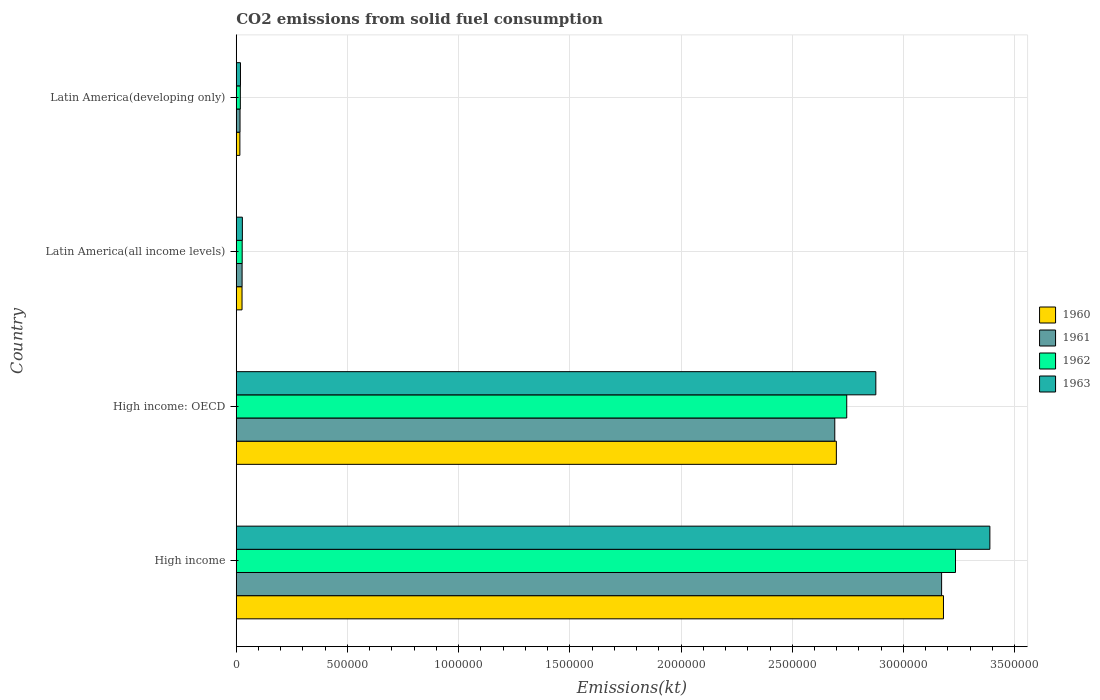How many different coloured bars are there?
Offer a very short reply. 4. How many groups of bars are there?
Your answer should be compact. 4. How many bars are there on the 2nd tick from the top?
Your response must be concise. 4. What is the label of the 2nd group of bars from the top?
Provide a succinct answer. Latin America(all income levels). In how many cases, is the number of bars for a given country not equal to the number of legend labels?
Your answer should be compact. 0. What is the amount of CO2 emitted in 1961 in High income?
Offer a very short reply. 3.17e+06. Across all countries, what is the maximum amount of CO2 emitted in 1962?
Your answer should be compact. 3.23e+06. Across all countries, what is the minimum amount of CO2 emitted in 1961?
Ensure brevity in your answer.  1.70e+04. In which country was the amount of CO2 emitted in 1962 maximum?
Keep it short and to the point. High income. In which country was the amount of CO2 emitted in 1962 minimum?
Your answer should be compact. Latin America(developing only). What is the total amount of CO2 emitted in 1963 in the graph?
Give a very brief answer. 6.31e+06. What is the difference between the amount of CO2 emitted in 1960 in High income: OECD and that in Latin America(all income levels)?
Offer a terse response. 2.67e+06. What is the difference between the amount of CO2 emitted in 1963 in Latin America(all income levels) and the amount of CO2 emitted in 1961 in High income: OECD?
Keep it short and to the point. -2.66e+06. What is the average amount of CO2 emitted in 1963 per country?
Your answer should be very brief. 1.58e+06. What is the difference between the amount of CO2 emitted in 1963 and amount of CO2 emitted in 1962 in Latin America(all income levels)?
Offer a very short reply. 858.84. In how many countries, is the amount of CO2 emitted in 1960 greater than 3200000 kt?
Offer a very short reply. 0. What is the ratio of the amount of CO2 emitted in 1961 in High income: OECD to that in Latin America(all income levels)?
Your answer should be very brief. 102.49. Is the amount of CO2 emitted in 1962 in High income: OECD less than that in Latin America(developing only)?
Provide a short and direct response. No. What is the difference between the highest and the second highest amount of CO2 emitted in 1962?
Your answer should be compact. 4.89e+05. What is the difference between the highest and the lowest amount of CO2 emitted in 1961?
Ensure brevity in your answer.  3.15e+06. In how many countries, is the amount of CO2 emitted in 1961 greater than the average amount of CO2 emitted in 1961 taken over all countries?
Offer a very short reply. 2. Is the sum of the amount of CO2 emitted in 1961 in High income: OECD and Latin America(all income levels) greater than the maximum amount of CO2 emitted in 1960 across all countries?
Provide a succinct answer. No. Is it the case that in every country, the sum of the amount of CO2 emitted in 1962 and amount of CO2 emitted in 1960 is greater than the sum of amount of CO2 emitted in 1963 and amount of CO2 emitted in 1961?
Your answer should be very brief. No. What does the 4th bar from the bottom in Latin America(developing only) represents?
Keep it short and to the point. 1963. How many bars are there?
Keep it short and to the point. 16. Are all the bars in the graph horizontal?
Keep it short and to the point. Yes. What is the difference between two consecutive major ticks on the X-axis?
Offer a very short reply. 5.00e+05. Where does the legend appear in the graph?
Your answer should be compact. Center right. How many legend labels are there?
Your answer should be compact. 4. What is the title of the graph?
Keep it short and to the point. CO2 emissions from solid fuel consumption. Does "1963" appear as one of the legend labels in the graph?
Provide a succinct answer. Yes. What is the label or title of the X-axis?
Ensure brevity in your answer.  Emissions(kt). What is the Emissions(kt) of 1960 in High income?
Offer a terse response. 3.18e+06. What is the Emissions(kt) in 1961 in High income?
Your answer should be very brief. 3.17e+06. What is the Emissions(kt) of 1962 in High income?
Offer a terse response. 3.23e+06. What is the Emissions(kt) in 1963 in High income?
Offer a very short reply. 3.39e+06. What is the Emissions(kt) in 1960 in High income: OECD?
Give a very brief answer. 2.70e+06. What is the Emissions(kt) of 1961 in High income: OECD?
Make the answer very short. 2.69e+06. What is the Emissions(kt) of 1962 in High income: OECD?
Give a very brief answer. 2.75e+06. What is the Emissions(kt) of 1963 in High income: OECD?
Make the answer very short. 2.88e+06. What is the Emissions(kt) in 1960 in Latin America(all income levels)?
Keep it short and to the point. 2.60e+04. What is the Emissions(kt) in 1961 in Latin America(all income levels)?
Keep it short and to the point. 2.63e+04. What is the Emissions(kt) of 1962 in Latin America(all income levels)?
Your response must be concise. 2.67e+04. What is the Emissions(kt) of 1963 in Latin America(all income levels)?
Your answer should be compact. 2.75e+04. What is the Emissions(kt) of 1960 in Latin America(developing only)?
Keep it short and to the point. 1.62e+04. What is the Emissions(kt) of 1961 in Latin America(developing only)?
Ensure brevity in your answer.  1.70e+04. What is the Emissions(kt) in 1962 in Latin America(developing only)?
Your answer should be compact. 1.83e+04. What is the Emissions(kt) in 1963 in Latin America(developing only)?
Offer a terse response. 1.90e+04. Across all countries, what is the maximum Emissions(kt) of 1960?
Ensure brevity in your answer.  3.18e+06. Across all countries, what is the maximum Emissions(kt) of 1961?
Give a very brief answer. 3.17e+06. Across all countries, what is the maximum Emissions(kt) of 1962?
Ensure brevity in your answer.  3.23e+06. Across all countries, what is the maximum Emissions(kt) in 1963?
Your response must be concise. 3.39e+06. Across all countries, what is the minimum Emissions(kt) in 1960?
Provide a short and direct response. 1.62e+04. Across all countries, what is the minimum Emissions(kt) of 1961?
Offer a very short reply. 1.70e+04. Across all countries, what is the minimum Emissions(kt) of 1962?
Ensure brevity in your answer.  1.83e+04. Across all countries, what is the minimum Emissions(kt) of 1963?
Offer a very short reply. 1.90e+04. What is the total Emissions(kt) in 1960 in the graph?
Your answer should be very brief. 5.92e+06. What is the total Emissions(kt) in 1961 in the graph?
Your answer should be very brief. 5.91e+06. What is the total Emissions(kt) in 1962 in the graph?
Ensure brevity in your answer.  6.02e+06. What is the total Emissions(kt) in 1963 in the graph?
Make the answer very short. 6.31e+06. What is the difference between the Emissions(kt) of 1960 in High income and that in High income: OECD?
Provide a short and direct response. 4.82e+05. What is the difference between the Emissions(kt) of 1961 in High income and that in High income: OECD?
Provide a short and direct response. 4.80e+05. What is the difference between the Emissions(kt) of 1962 in High income and that in High income: OECD?
Give a very brief answer. 4.89e+05. What is the difference between the Emissions(kt) of 1963 in High income and that in High income: OECD?
Ensure brevity in your answer.  5.13e+05. What is the difference between the Emissions(kt) of 1960 in High income and that in Latin America(all income levels)?
Ensure brevity in your answer.  3.15e+06. What is the difference between the Emissions(kt) of 1961 in High income and that in Latin America(all income levels)?
Your response must be concise. 3.15e+06. What is the difference between the Emissions(kt) of 1962 in High income and that in Latin America(all income levels)?
Offer a terse response. 3.21e+06. What is the difference between the Emissions(kt) of 1963 in High income and that in Latin America(all income levels)?
Your response must be concise. 3.36e+06. What is the difference between the Emissions(kt) in 1960 in High income and that in Latin America(developing only)?
Offer a terse response. 3.16e+06. What is the difference between the Emissions(kt) in 1961 in High income and that in Latin America(developing only)?
Provide a short and direct response. 3.15e+06. What is the difference between the Emissions(kt) in 1962 in High income and that in Latin America(developing only)?
Provide a short and direct response. 3.22e+06. What is the difference between the Emissions(kt) in 1963 in High income and that in Latin America(developing only)?
Your answer should be compact. 3.37e+06. What is the difference between the Emissions(kt) of 1960 in High income: OECD and that in Latin America(all income levels)?
Offer a very short reply. 2.67e+06. What is the difference between the Emissions(kt) in 1961 in High income: OECD and that in Latin America(all income levels)?
Offer a very short reply. 2.67e+06. What is the difference between the Emissions(kt) in 1962 in High income: OECD and that in Latin America(all income levels)?
Provide a short and direct response. 2.72e+06. What is the difference between the Emissions(kt) in 1963 in High income: OECD and that in Latin America(all income levels)?
Your response must be concise. 2.85e+06. What is the difference between the Emissions(kt) in 1960 in High income: OECD and that in Latin America(developing only)?
Offer a very short reply. 2.68e+06. What is the difference between the Emissions(kt) of 1961 in High income: OECD and that in Latin America(developing only)?
Provide a short and direct response. 2.67e+06. What is the difference between the Emissions(kt) of 1962 in High income: OECD and that in Latin America(developing only)?
Provide a succinct answer. 2.73e+06. What is the difference between the Emissions(kt) of 1963 in High income: OECD and that in Latin America(developing only)?
Your answer should be compact. 2.86e+06. What is the difference between the Emissions(kt) of 1960 in Latin America(all income levels) and that in Latin America(developing only)?
Make the answer very short. 9759.8. What is the difference between the Emissions(kt) of 1961 in Latin America(all income levels) and that in Latin America(developing only)?
Your answer should be very brief. 9282.45. What is the difference between the Emissions(kt) of 1962 in Latin America(all income levels) and that in Latin America(developing only)?
Your response must be concise. 8301.83. What is the difference between the Emissions(kt) of 1963 in Latin America(all income levels) and that in Latin America(developing only)?
Give a very brief answer. 8542.91. What is the difference between the Emissions(kt) in 1960 in High income and the Emissions(kt) in 1961 in High income: OECD?
Give a very brief answer. 4.89e+05. What is the difference between the Emissions(kt) of 1960 in High income and the Emissions(kt) of 1962 in High income: OECD?
Offer a terse response. 4.35e+05. What is the difference between the Emissions(kt) in 1960 in High income and the Emissions(kt) in 1963 in High income: OECD?
Offer a very short reply. 3.04e+05. What is the difference between the Emissions(kt) of 1961 in High income and the Emissions(kt) of 1962 in High income: OECD?
Your response must be concise. 4.27e+05. What is the difference between the Emissions(kt) in 1961 in High income and the Emissions(kt) in 1963 in High income: OECD?
Give a very brief answer. 2.96e+05. What is the difference between the Emissions(kt) in 1962 in High income and the Emissions(kt) in 1963 in High income: OECD?
Your answer should be very brief. 3.58e+05. What is the difference between the Emissions(kt) of 1960 in High income and the Emissions(kt) of 1961 in Latin America(all income levels)?
Your response must be concise. 3.15e+06. What is the difference between the Emissions(kt) in 1960 in High income and the Emissions(kt) in 1962 in Latin America(all income levels)?
Keep it short and to the point. 3.15e+06. What is the difference between the Emissions(kt) of 1960 in High income and the Emissions(kt) of 1963 in Latin America(all income levels)?
Give a very brief answer. 3.15e+06. What is the difference between the Emissions(kt) in 1961 in High income and the Emissions(kt) in 1962 in Latin America(all income levels)?
Offer a very short reply. 3.15e+06. What is the difference between the Emissions(kt) of 1961 in High income and the Emissions(kt) of 1963 in Latin America(all income levels)?
Your answer should be very brief. 3.14e+06. What is the difference between the Emissions(kt) in 1962 in High income and the Emissions(kt) in 1963 in Latin America(all income levels)?
Ensure brevity in your answer.  3.21e+06. What is the difference between the Emissions(kt) in 1960 in High income and the Emissions(kt) in 1961 in Latin America(developing only)?
Your answer should be very brief. 3.16e+06. What is the difference between the Emissions(kt) of 1960 in High income and the Emissions(kt) of 1962 in Latin America(developing only)?
Keep it short and to the point. 3.16e+06. What is the difference between the Emissions(kt) in 1960 in High income and the Emissions(kt) in 1963 in Latin America(developing only)?
Ensure brevity in your answer.  3.16e+06. What is the difference between the Emissions(kt) of 1961 in High income and the Emissions(kt) of 1962 in Latin America(developing only)?
Offer a terse response. 3.15e+06. What is the difference between the Emissions(kt) in 1961 in High income and the Emissions(kt) in 1963 in Latin America(developing only)?
Your answer should be compact. 3.15e+06. What is the difference between the Emissions(kt) in 1962 in High income and the Emissions(kt) in 1963 in Latin America(developing only)?
Give a very brief answer. 3.22e+06. What is the difference between the Emissions(kt) in 1960 in High income: OECD and the Emissions(kt) in 1961 in Latin America(all income levels)?
Your answer should be very brief. 2.67e+06. What is the difference between the Emissions(kt) of 1960 in High income: OECD and the Emissions(kt) of 1962 in Latin America(all income levels)?
Offer a terse response. 2.67e+06. What is the difference between the Emissions(kt) in 1960 in High income: OECD and the Emissions(kt) in 1963 in Latin America(all income levels)?
Give a very brief answer. 2.67e+06. What is the difference between the Emissions(kt) of 1961 in High income: OECD and the Emissions(kt) of 1962 in Latin America(all income levels)?
Give a very brief answer. 2.66e+06. What is the difference between the Emissions(kt) in 1961 in High income: OECD and the Emissions(kt) in 1963 in Latin America(all income levels)?
Offer a very short reply. 2.66e+06. What is the difference between the Emissions(kt) of 1962 in High income: OECD and the Emissions(kt) of 1963 in Latin America(all income levels)?
Your answer should be compact. 2.72e+06. What is the difference between the Emissions(kt) in 1960 in High income: OECD and the Emissions(kt) in 1961 in Latin America(developing only)?
Offer a very short reply. 2.68e+06. What is the difference between the Emissions(kt) in 1960 in High income: OECD and the Emissions(kt) in 1962 in Latin America(developing only)?
Provide a succinct answer. 2.68e+06. What is the difference between the Emissions(kt) in 1960 in High income: OECD and the Emissions(kt) in 1963 in Latin America(developing only)?
Provide a short and direct response. 2.68e+06. What is the difference between the Emissions(kt) in 1961 in High income: OECD and the Emissions(kt) in 1962 in Latin America(developing only)?
Ensure brevity in your answer.  2.67e+06. What is the difference between the Emissions(kt) of 1961 in High income: OECD and the Emissions(kt) of 1963 in Latin America(developing only)?
Make the answer very short. 2.67e+06. What is the difference between the Emissions(kt) of 1962 in High income: OECD and the Emissions(kt) of 1963 in Latin America(developing only)?
Ensure brevity in your answer.  2.73e+06. What is the difference between the Emissions(kt) of 1960 in Latin America(all income levels) and the Emissions(kt) of 1961 in Latin America(developing only)?
Ensure brevity in your answer.  9031.46. What is the difference between the Emissions(kt) in 1960 in Latin America(all income levels) and the Emissions(kt) in 1962 in Latin America(developing only)?
Offer a terse response. 7658.68. What is the difference between the Emissions(kt) in 1960 in Latin America(all income levels) and the Emissions(kt) in 1963 in Latin America(developing only)?
Your answer should be very brief. 7040.93. What is the difference between the Emissions(kt) of 1961 in Latin America(all income levels) and the Emissions(kt) of 1962 in Latin America(developing only)?
Your response must be concise. 7909.66. What is the difference between the Emissions(kt) of 1961 in Latin America(all income levels) and the Emissions(kt) of 1963 in Latin America(developing only)?
Your answer should be very brief. 7291.91. What is the difference between the Emissions(kt) of 1962 in Latin America(all income levels) and the Emissions(kt) of 1963 in Latin America(developing only)?
Give a very brief answer. 7684.07. What is the average Emissions(kt) in 1960 per country?
Offer a very short reply. 1.48e+06. What is the average Emissions(kt) in 1961 per country?
Offer a very short reply. 1.48e+06. What is the average Emissions(kt) of 1962 per country?
Give a very brief answer. 1.51e+06. What is the average Emissions(kt) in 1963 per country?
Offer a very short reply. 1.58e+06. What is the difference between the Emissions(kt) of 1960 and Emissions(kt) of 1961 in High income?
Offer a very short reply. 8354.42. What is the difference between the Emissions(kt) of 1960 and Emissions(kt) of 1962 in High income?
Your response must be concise. -5.41e+04. What is the difference between the Emissions(kt) in 1960 and Emissions(kt) in 1963 in High income?
Give a very brief answer. -2.09e+05. What is the difference between the Emissions(kt) in 1961 and Emissions(kt) in 1962 in High income?
Provide a short and direct response. -6.24e+04. What is the difference between the Emissions(kt) of 1961 and Emissions(kt) of 1963 in High income?
Provide a short and direct response. -2.17e+05. What is the difference between the Emissions(kt) of 1962 and Emissions(kt) of 1963 in High income?
Give a very brief answer. -1.55e+05. What is the difference between the Emissions(kt) of 1960 and Emissions(kt) of 1961 in High income: OECD?
Offer a terse response. 7090.26. What is the difference between the Emissions(kt) in 1960 and Emissions(kt) in 1962 in High income: OECD?
Your answer should be compact. -4.67e+04. What is the difference between the Emissions(kt) of 1960 and Emissions(kt) of 1963 in High income: OECD?
Provide a short and direct response. -1.77e+05. What is the difference between the Emissions(kt) in 1961 and Emissions(kt) in 1962 in High income: OECD?
Keep it short and to the point. -5.38e+04. What is the difference between the Emissions(kt) of 1961 and Emissions(kt) of 1963 in High income: OECD?
Ensure brevity in your answer.  -1.85e+05. What is the difference between the Emissions(kt) in 1962 and Emissions(kt) in 1963 in High income: OECD?
Your answer should be very brief. -1.31e+05. What is the difference between the Emissions(kt) in 1960 and Emissions(kt) in 1961 in Latin America(all income levels)?
Your answer should be compact. -250.98. What is the difference between the Emissions(kt) of 1960 and Emissions(kt) of 1962 in Latin America(all income levels)?
Make the answer very short. -643.15. What is the difference between the Emissions(kt) in 1960 and Emissions(kt) in 1963 in Latin America(all income levels)?
Your answer should be compact. -1501.98. What is the difference between the Emissions(kt) of 1961 and Emissions(kt) of 1962 in Latin America(all income levels)?
Give a very brief answer. -392.16. What is the difference between the Emissions(kt) in 1961 and Emissions(kt) in 1963 in Latin America(all income levels)?
Keep it short and to the point. -1251. What is the difference between the Emissions(kt) of 1962 and Emissions(kt) of 1963 in Latin America(all income levels)?
Your response must be concise. -858.84. What is the difference between the Emissions(kt) in 1960 and Emissions(kt) in 1961 in Latin America(developing only)?
Offer a terse response. -728.34. What is the difference between the Emissions(kt) in 1960 and Emissions(kt) in 1962 in Latin America(developing only)?
Ensure brevity in your answer.  -2101.12. What is the difference between the Emissions(kt) in 1960 and Emissions(kt) in 1963 in Latin America(developing only)?
Offer a terse response. -2718.88. What is the difference between the Emissions(kt) in 1961 and Emissions(kt) in 1962 in Latin America(developing only)?
Offer a very short reply. -1372.79. What is the difference between the Emissions(kt) of 1961 and Emissions(kt) of 1963 in Latin America(developing only)?
Your answer should be compact. -1990.54. What is the difference between the Emissions(kt) in 1962 and Emissions(kt) in 1963 in Latin America(developing only)?
Offer a very short reply. -617.75. What is the ratio of the Emissions(kt) in 1960 in High income to that in High income: OECD?
Offer a terse response. 1.18. What is the ratio of the Emissions(kt) in 1961 in High income to that in High income: OECD?
Offer a terse response. 1.18. What is the ratio of the Emissions(kt) in 1962 in High income to that in High income: OECD?
Your answer should be very brief. 1.18. What is the ratio of the Emissions(kt) of 1963 in High income to that in High income: OECD?
Offer a very short reply. 1.18. What is the ratio of the Emissions(kt) of 1960 in High income to that in Latin America(all income levels)?
Ensure brevity in your answer.  122.27. What is the ratio of the Emissions(kt) of 1961 in High income to that in Latin America(all income levels)?
Provide a succinct answer. 120.78. What is the ratio of the Emissions(kt) in 1962 in High income to that in Latin America(all income levels)?
Your answer should be compact. 121.35. What is the ratio of the Emissions(kt) of 1963 in High income to that in Latin America(all income levels)?
Provide a short and direct response. 123.18. What is the ratio of the Emissions(kt) in 1960 in High income to that in Latin America(developing only)?
Offer a very short reply. 195.71. What is the ratio of the Emissions(kt) in 1961 in High income to that in Latin America(developing only)?
Provide a short and direct response. 186.83. What is the ratio of the Emissions(kt) in 1962 in High income to that in Latin America(developing only)?
Make the answer very short. 176.25. What is the ratio of the Emissions(kt) in 1963 in High income to that in Latin America(developing only)?
Provide a succinct answer. 178.66. What is the ratio of the Emissions(kt) of 1960 in High income: OECD to that in Latin America(all income levels)?
Ensure brevity in your answer.  103.75. What is the ratio of the Emissions(kt) in 1961 in High income: OECD to that in Latin America(all income levels)?
Offer a very short reply. 102.49. What is the ratio of the Emissions(kt) in 1962 in High income: OECD to that in Latin America(all income levels)?
Provide a succinct answer. 103. What is the ratio of the Emissions(kt) in 1963 in High income: OECD to that in Latin America(all income levels)?
Ensure brevity in your answer.  104.54. What is the ratio of the Emissions(kt) of 1960 in High income: OECD to that in Latin America(developing only)?
Give a very brief answer. 166.07. What is the ratio of the Emissions(kt) in 1961 in High income: OECD to that in Latin America(developing only)?
Provide a short and direct response. 158.53. What is the ratio of the Emissions(kt) in 1962 in High income: OECD to that in Latin America(developing only)?
Offer a terse response. 149.6. What is the ratio of the Emissions(kt) in 1963 in High income: OECD to that in Latin America(developing only)?
Your response must be concise. 151.62. What is the ratio of the Emissions(kt) of 1960 in Latin America(all income levels) to that in Latin America(developing only)?
Ensure brevity in your answer.  1.6. What is the ratio of the Emissions(kt) in 1961 in Latin America(all income levels) to that in Latin America(developing only)?
Provide a succinct answer. 1.55. What is the ratio of the Emissions(kt) in 1962 in Latin America(all income levels) to that in Latin America(developing only)?
Provide a succinct answer. 1.45. What is the ratio of the Emissions(kt) of 1963 in Latin America(all income levels) to that in Latin America(developing only)?
Your response must be concise. 1.45. What is the difference between the highest and the second highest Emissions(kt) of 1960?
Provide a succinct answer. 4.82e+05. What is the difference between the highest and the second highest Emissions(kt) in 1961?
Give a very brief answer. 4.80e+05. What is the difference between the highest and the second highest Emissions(kt) of 1962?
Provide a succinct answer. 4.89e+05. What is the difference between the highest and the second highest Emissions(kt) of 1963?
Make the answer very short. 5.13e+05. What is the difference between the highest and the lowest Emissions(kt) in 1960?
Ensure brevity in your answer.  3.16e+06. What is the difference between the highest and the lowest Emissions(kt) of 1961?
Provide a succinct answer. 3.15e+06. What is the difference between the highest and the lowest Emissions(kt) in 1962?
Ensure brevity in your answer.  3.22e+06. What is the difference between the highest and the lowest Emissions(kt) of 1963?
Your answer should be very brief. 3.37e+06. 